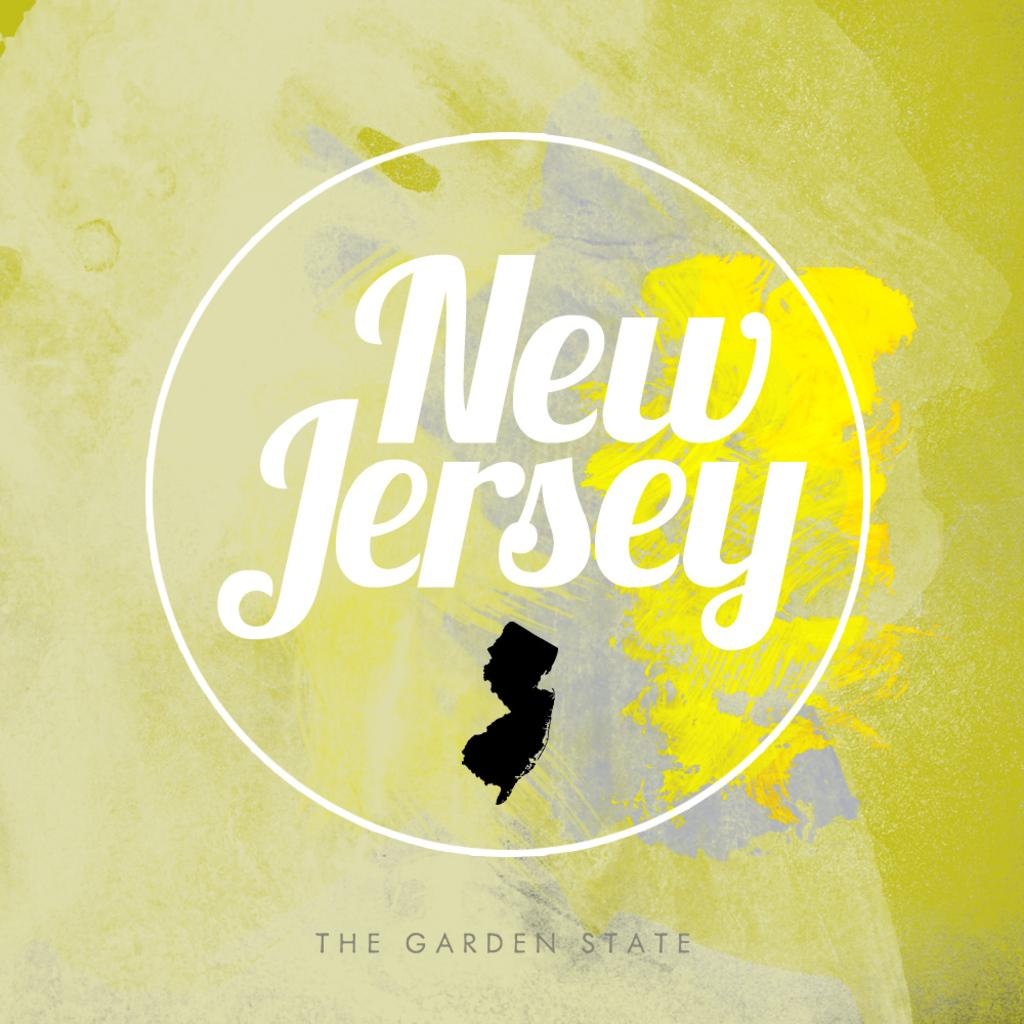<image>
Provide a brief description of the given image. A colorful design for New Jersey the garden state. 